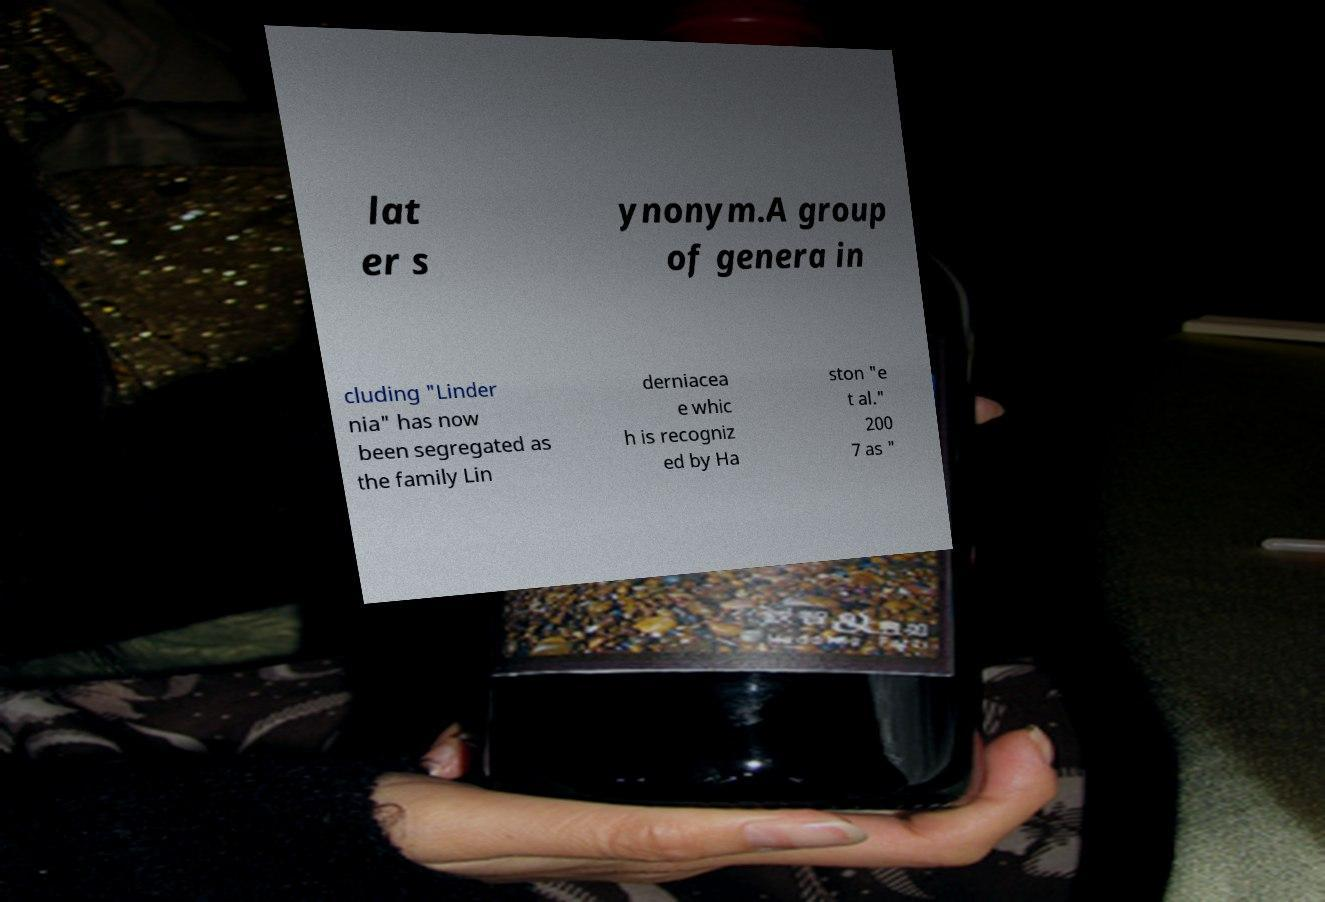For documentation purposes, I need the text within this image transcribed. Could you provide that? lat er s ynonym.A group of genera in cluding "Linder nia" has now been segregated as the family Lin derniacea e whic h is recogniz ed by Ha ston "e t al." 200 7 as " 